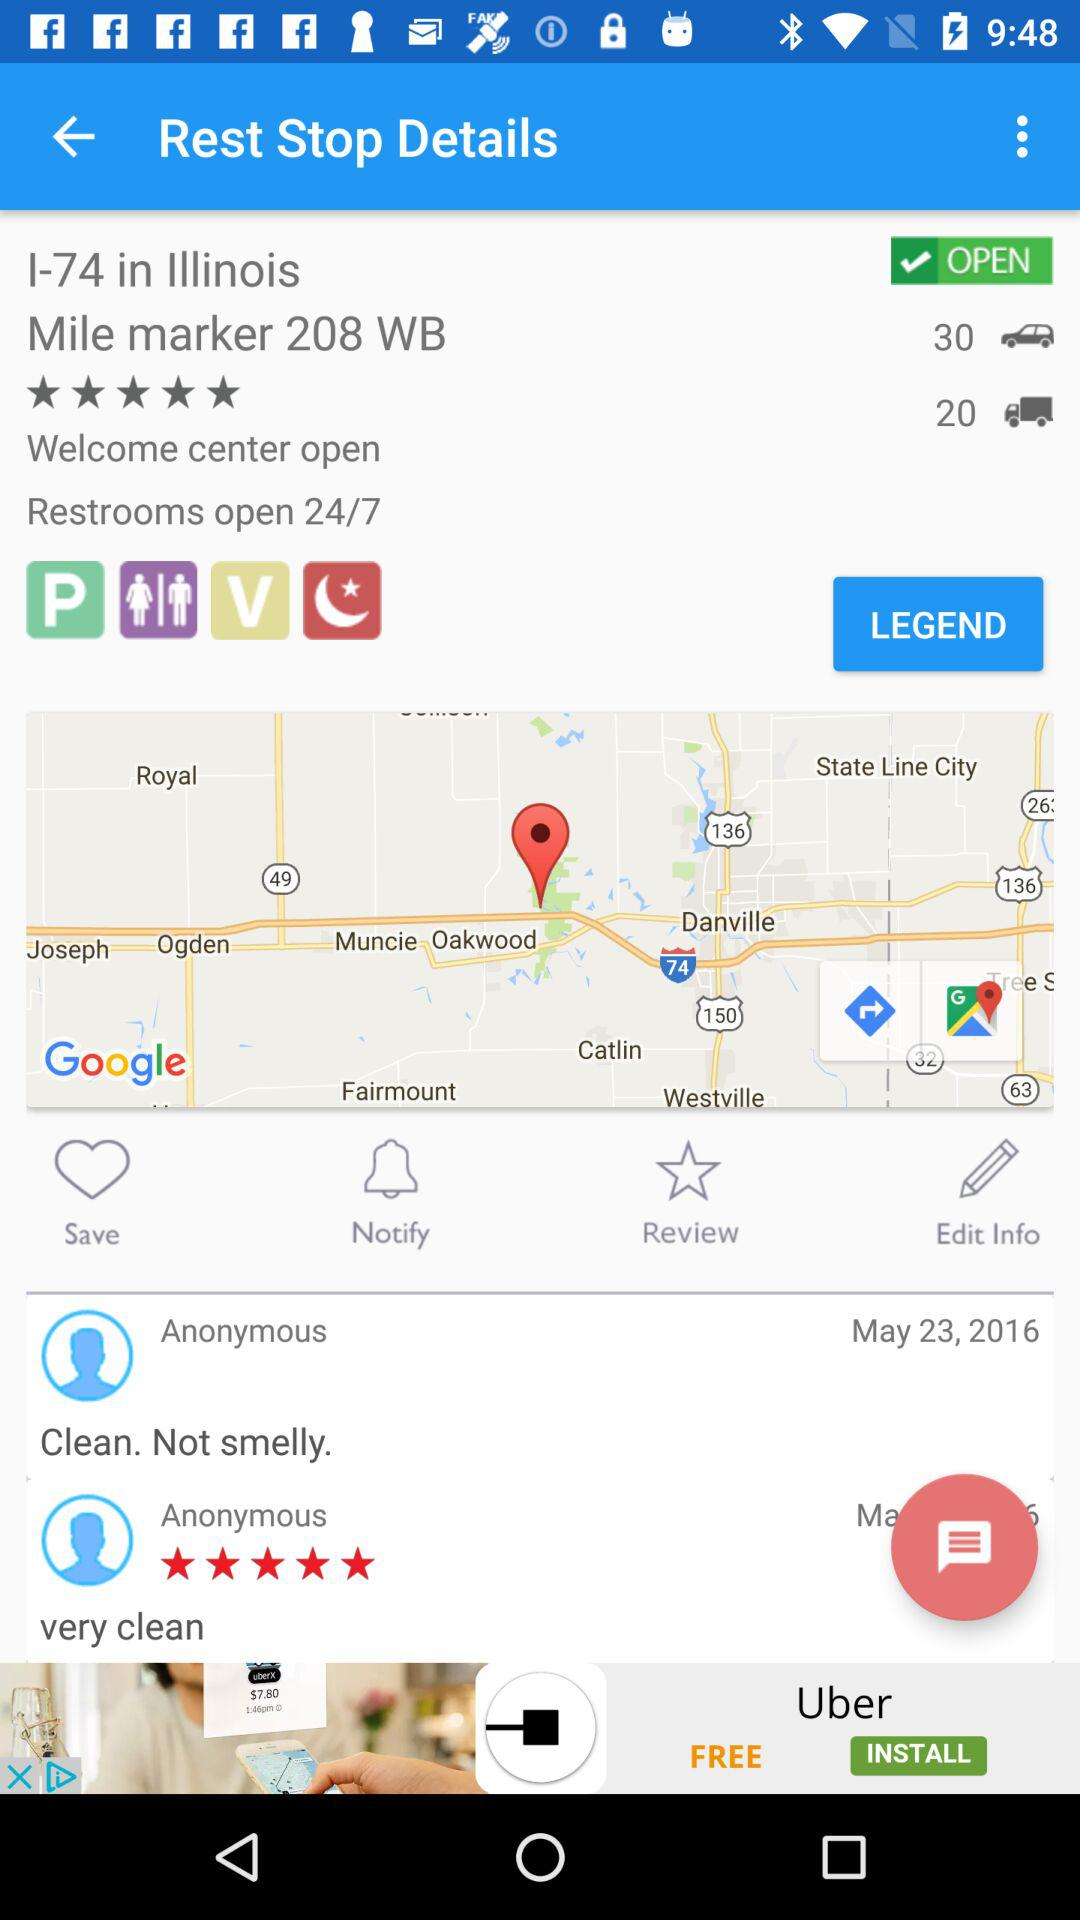On what date was the review "Clean. Not smelly." posted? The review "Clean. Not smelly." was posted on May 23, 2016. 